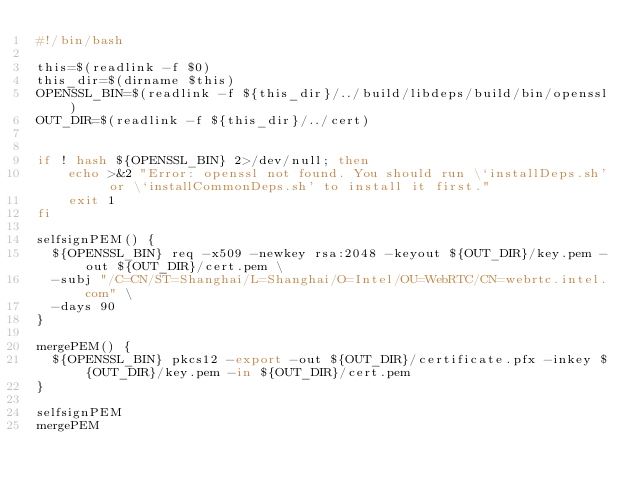<code> <loc_0><loc_0><loc_500><loc_500><_Bash_>#!/bin/bash

this=$(readlink -f $0)
this_dir=$(dirname $this)
OPENSSL_BIN=$(readlink -f ${this_dir}/../build/libdeps/build/bin/openssl)
OUT_DIR=$(readlink -f ${this_dir}/../cert)


if ! hash ${OPENSSL_BIN} 2>/dev/null; then
    echo >&2 "Error: openssl not found. You should run \`installDeps.sh' or \`installCommonDeps.sh' to install it first."
    exit 1
fi

selfsignPEM() {
  ${OPENSSL_BIN} req -x509 -newkey rsa:2048 -keyout ${OUT_DIR}/key.pem -out ${OUT_DIR}/cert.pem \
  -subj "/C=CN/ST=Shanghai/L=Shanghai/O=Intel/OU=WebRTC/CN=webrtc.intel.com" \
  -days 90
}

mergePEM() {
  ${OPENSSL_BIN} pkcs12 -export -out ${OUT_DIR}/certificate.pfx -inkey ${OUT_DIR}/key.pem -in ${OUT_DIR}/cert.pem
}

selfsignPEM
mergePEM</code> 